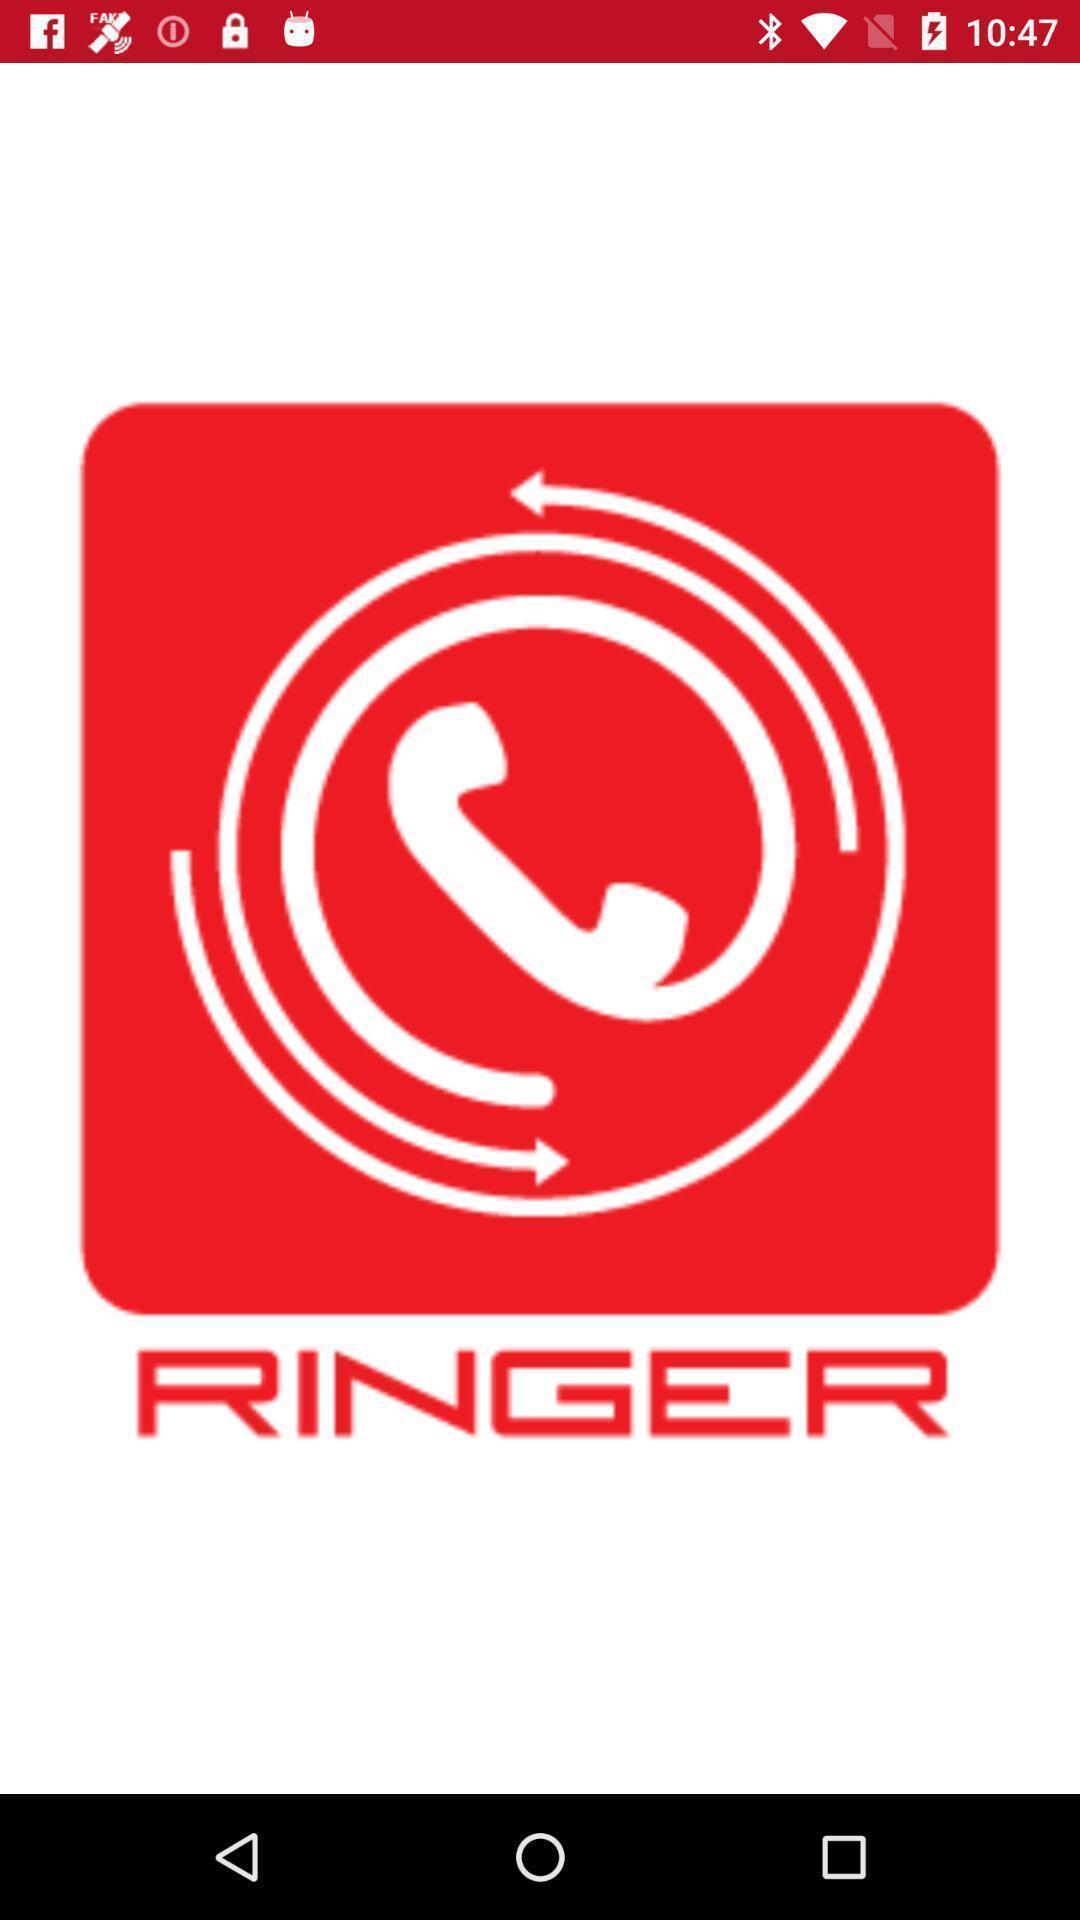Provide a description of this screenshot. Welcome page of a calling app. 